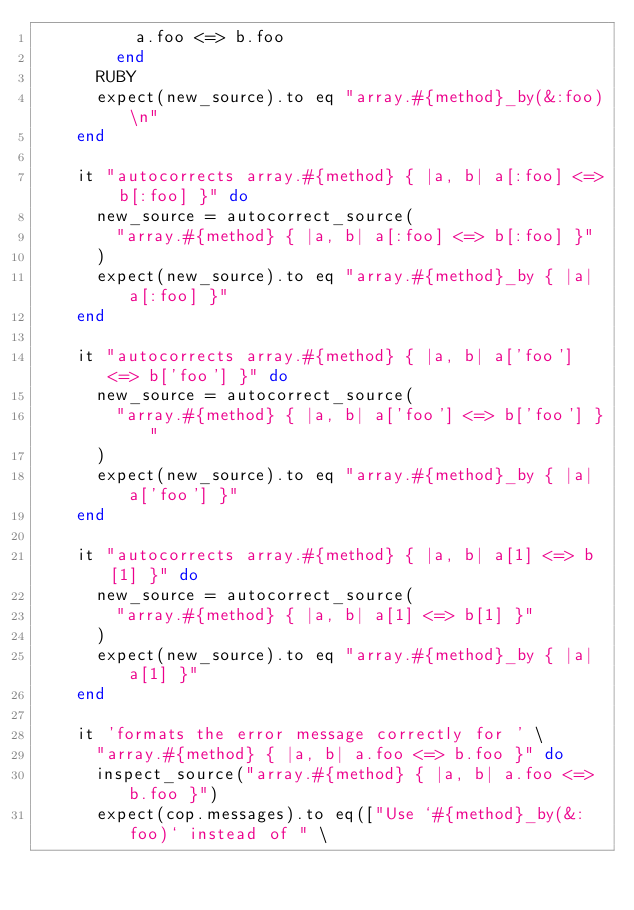<code> <loc_0><loc_0><loc_500><loc_500><_Ruby_>          a.foo <=> b.foo
        end
      RUBY
      expect(new_source).to eq "array.#{method}_by(&:foo)\n"
    end

    it "autocorrects array.#{method} { |a, b| a[:foo] <=> b[:foo] }" do
      new_source = autocorrect_source(
        "array.#{method} { |a, b| a[:foo] <=> b[:foo] }"
      )
      expect(new_source).to eq "array.#{method}_by { |a| a[:foo] }"
    end

    it "autocorrects array.#{method} { |a, b| a['foo'] <=> b['foo'] }" do
      new_source = autocorrect_source(
        "array.#{method} { |a, b| a['foo'] <=> b['foo'] }"
      )
      expect(new_source).to eq "array.#{method}_by { |a| a['foo'] }"
    end

    it "autocorrects array.#{method} { |a, b| a[1] <=> b[1] }" do
      new_source = autocorrect_source(
        "array.#{method} { |a, b| a[1] <=> b[1] }"
      )
      expect(new_source).to eq "array.#{method}_by { |a| a[1] }"
    end

    it 'formats the error message correctly for ' \
      "array.#{method} { |a, b| a.foo <=> b.foo }" do
      inspect_source("array.#{method} { |a, b| a.foo <=> b.foo }")
      expect(cop.messages).to eq(["Use `#{method}_by(&:foo)` instead of " \</code> 